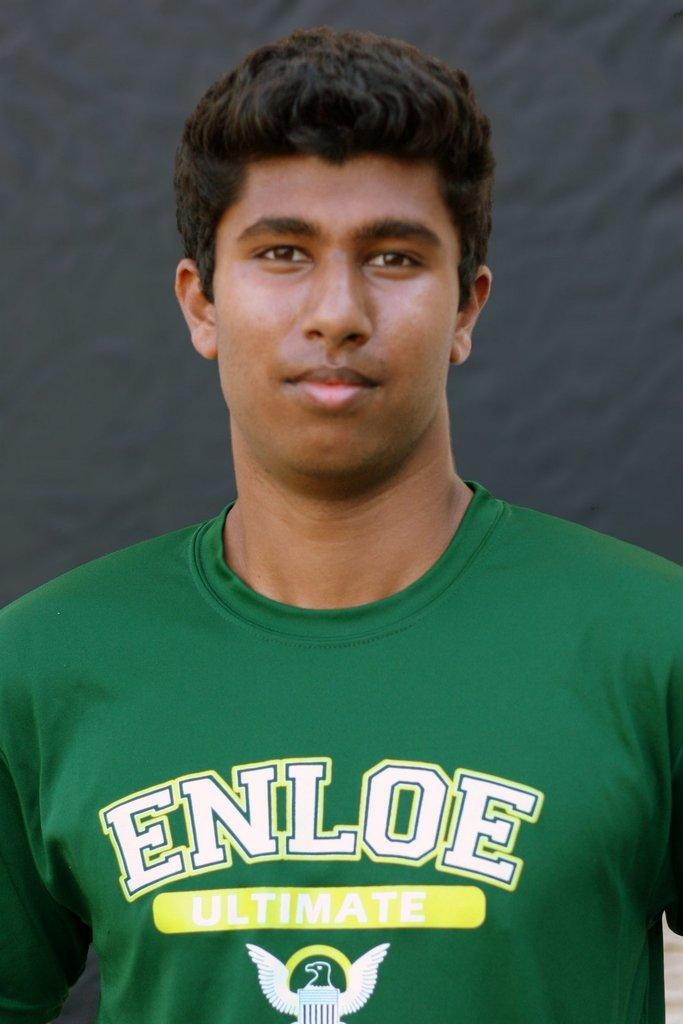<image>
Summarize the visual content of the image. A person is wearing a green shirt with the words Enloe Ultimate written on it. 